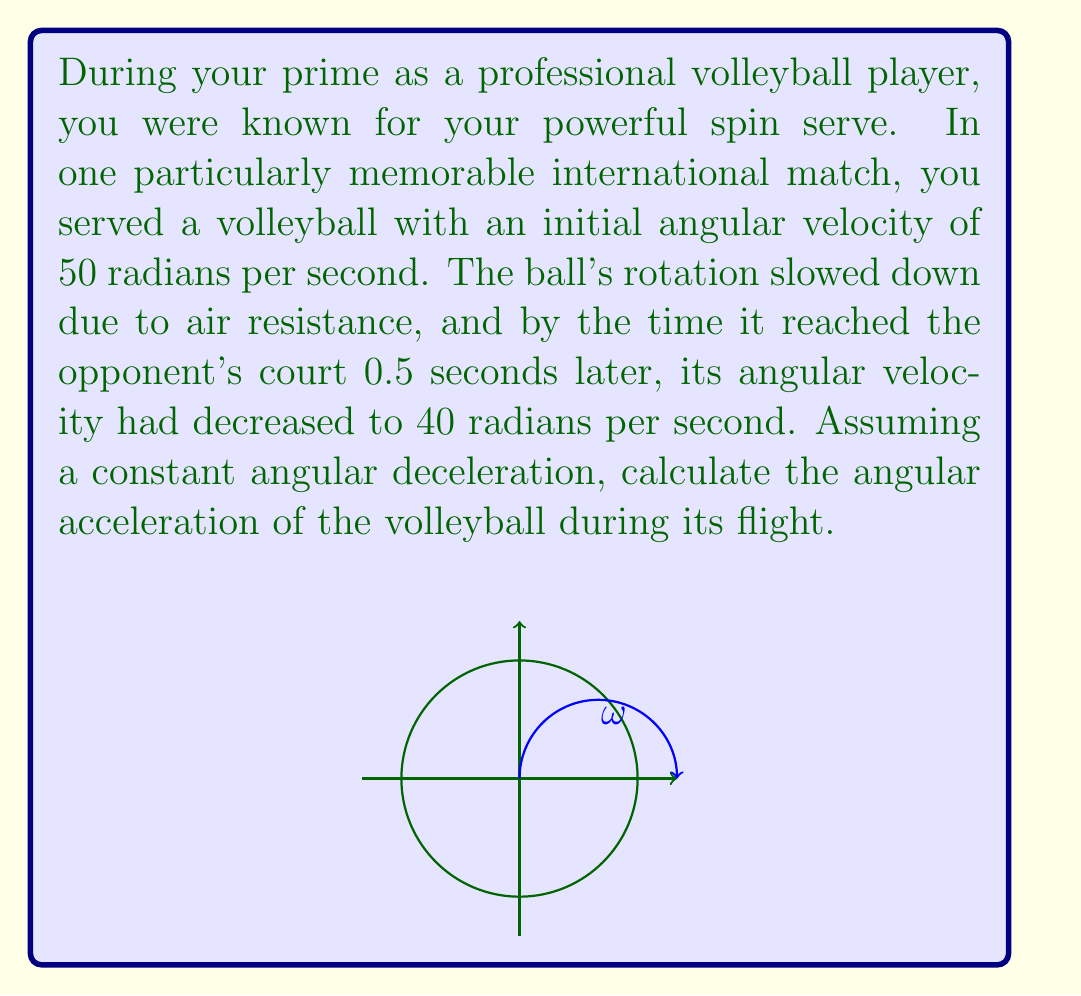Can you answer this question? Let's approach this step-by-step using the equations of rotational kinematics:

1) We know that for constant angular acceleration, we can use the equation:
   $$\omega = \omega_0 + \alpha t$$
   where $\omega$ is the final angular velocity, $\omega_0$ is the initial angular velocity, $\alpha$ is the angular acceleration, and $t$ is the time.

2) We are given:
   - Initial angular velocity, $\omega_0 = 50$ rad/s
   - Final angular velocity, $\omega = 40$ rad/s
   - Time, $t = 0.5$ s

3) Substituting these values into the equation:
   $$40 = 50 + \alpha(0.5)$$

4) Subtracting 50 from both sides:
   $$-10 = \alpha(0.5)$$

5) Dividing both sides by 0.5:
   $$\alpha = \frac{-10}{0.5} = -20$$

Therefore, the angular acceleration is -20 rad/s².

The negative sign indicates that the ball is decelerating, which matches our intuition as the ball slows down due to air resistance.
Answer: $-20$ rad/s² 